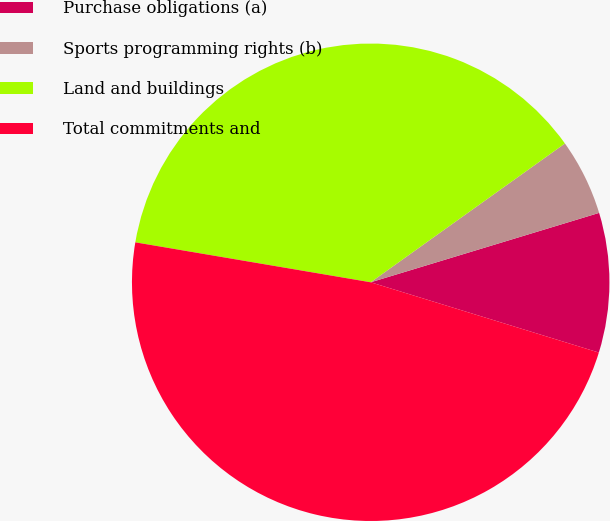Convert chart. <chart><loc_0><loc_0><loc_500><loc_500><pie_chart><fcel>Purchase obligations (a)<fcel>Sports programming rights (b)<fcel>Land and buildings<fcel>Total commitments and<nl><fcel>9.45%<fcel>5.18%<fcel>37.45%<fcel>47.92%<nl></chart> 